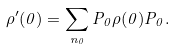Convert formula to latex. <formula><loc_0><loc_0><loc_500><loc_500>\rho ^ { \prime } ( 0 ) = \sum _ { n _ { 0 } } P _ { 0 } \rho ( 0 ) P _ { 0 } .</formula> 